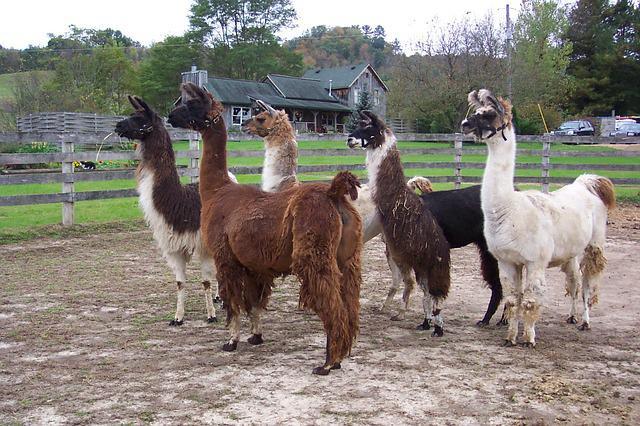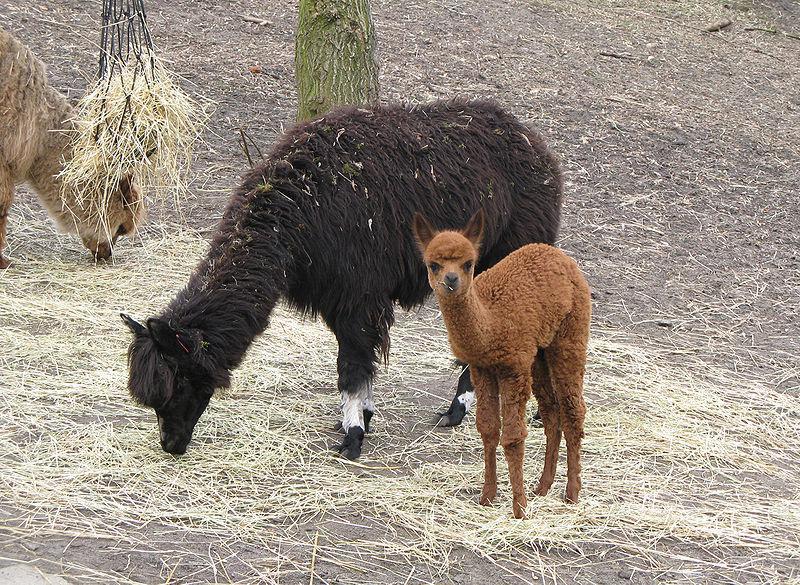The first image is the image on the left, the second image is the image on the right. Analyze the images presented: Is the assertion "The right image contains one right-facing llama wearing a head harness, and the left image contains two llamas with bodies turned to the left." valid? Answer yes or no. No. The first image is the image on the left, the second image is the image on the right. Examine the images to the left and right. Is the description "One llama is looking to the right." accurate? Answer yes or no. No. 